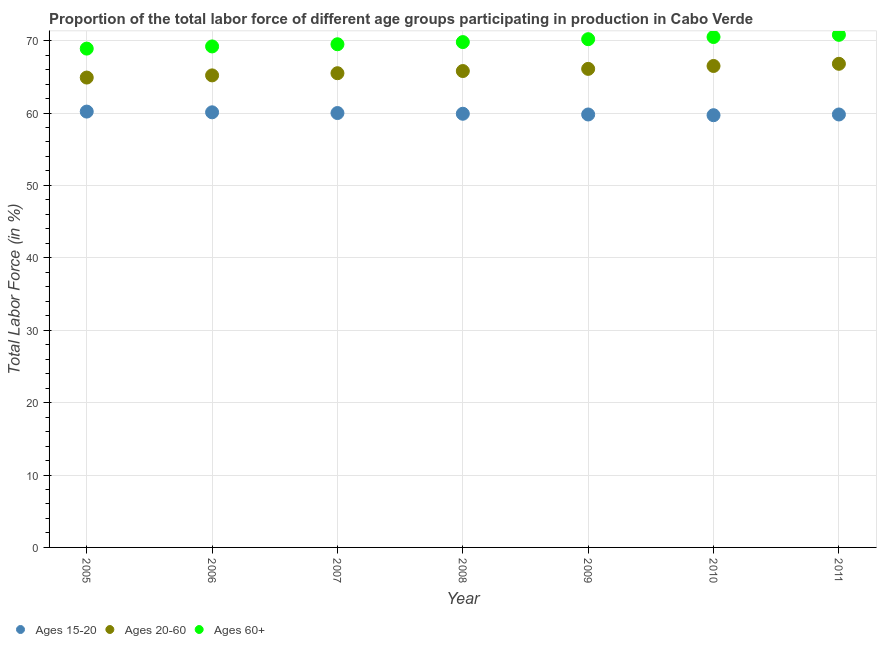Is the number of dotlines equal to the number of legend labels?
Your answer should be compact. Yes. What is the percentage of labor force within the age group 15-20 in 2005?
Your answer should be compact. 60.2. Across all years, what is the maximum percentage of labor force within the age group 20-60?
Your response must be concise. 66.8. Across all years, what is the minimum percentage of labor force within the age group 15-20?
Provide a short and direct response. 59.7. In which year was the percentage of labor force within the age group 20-60 maximum?
Keep it short and to the point. 2011. In which year was the percentage of labor force within the age group 20-60 minimum?
Your response must be concise. 2005. What is the total percentage of labor force within the age group 20-60 in the graph?
Your answer should be very brief. 460.8. What is the difference between the percentage of labor force within the age group 20-60 in 2010 and that in 2011?
Ensure brevity in your answer.  -0.3. What is the difference between the percentage of labor force within the age group 20-60 in 2011 and the percentage of labor force above age 60 in 2009?
Give a very brief answer. -3.4. What is the average percentage of labor force within the age group 20-60 per year?
Your response must be concise. 65.83. In the year 2006, what is the difference between the percentage of labor force within the age group 15-20 and percentage of labor force within the age group 20-60?
Your response must be concise. -5.1. In how many years, is the percentage of labor force within the age group 15-20 greater than 24 %?
Provide a succinct answer. 7. What is the ratio of the percentage of labor force above age 60 in 2009 to that in 2010?
Give a very brief answer. 1. Is the percentage of labor force within the age group 15-20 in 2009 less than that in 2011?
Your answer should be compact. No. What is the difference between the highest and the second highest percentage of labor force within the age group 20-60?
Provide a succinct answer. 0.3. What is the difference between the highest and the lowest percentage of labor force within the age group 20-60?
Provide a short and direct response. 1.9. Is the sum of the percentage of labor force within the age group 15-20 in 2007 and 2009 greater than the maximum percentage of labor force within the age group 20-60 across all years?
Give a very brief answer. Yes. Is it the case that in every year, the sum of the percentage of labor force within the age group 15-20 and percentage of labor force within the age group 20-60 is greater than the percentage of labor force above age 60?
Offer a terse response. Yes. Is the percentage of labor force within the age group 15-20 strictly less than the percentage of labor force within the age group 20-60 over the years?
Make the answer very short. Yes. How many dotlines are there?
Your response must be concise. 3. What is the difference between two consecutive major ticks on the Y-axis?
Give a very brief answer. 10. Are the values on the major ticks of Y-axis written in scientific E-notation?
Provide a succinct answer. No. Does the graph contain grids?
Your answer should be compact. Yes. How many legend labels are there?
Offer a very short reply. 3. What is the title of the graph?
Provide a succinct answer. Proportion of the total labor force of different age groups participating in production in Cabo Verde. What is the Total Labor Force (in %) of Ages 15-20 in 2005?
Your answer should be very brief. 60.2. What is the Total Labor Force (in %) in Ages 20-60 in 2005?
Your response must be concise. 64.9. What is the Total Labor Force (in %) of Ages 60+ in 2005?
Keep it short and to the point. 68.9. What is the Total Labor Force (in %) in Ages 15-20 in 2006?
Your response must be concise. 60.1. What is the Total Labor Force (in %) of Ages 20-60 in 2006?
Give a very brief answer. 65.2. What is the Total Labor Force (in %) of Ages 60+ in 2006?
Offer a terse response. 69.2. What is the Total Labor Force (in %) in Ages 20-60 in 2007?
Provide a short and direct response. 65.5. What is the Total Labor Force (in %) in Ages 60+ in 2007?
Your answer should be compact. 69.5. What is the Total Labor Force (in %) of Ages 15-20 in 2008?
Your answer should be very brief. 59.9. What is the Total Labor Force (in %) in Ages 20-60 in 2008?
Give a very brief answer. 65.8. What is the Total Labor Force (in %) of Ages 60+ in 2008?
Offer a very short reply. 69.8. What is the Total Labor Force (in %) of Ages 15-20 in 2009?
Provide a short and direct response. 59.8. What is the Total Labor Force (in %) in Ages 20-60 in 2009?
Your response must be concise. 66.1. What is the Total Labor Force (in %) of Ages 60+ in 2009?
Offer a very short reply. 70.2. What is the Total Labor Force (in %) of Ages 15-20 in 2010?
Offer a terse response. 59.7. What is the Total Labor Force (in %) in Ages 20-60 in 2010?
Your answer should be very brief. 66.5. What is the Total Labor Force (in %) in Ages 60+ in 2010?
Your answer should be very brief. 70.5. What is the Total Labor Force (in %) in Ages 15-20 in 2011?
Keep it short and to the point. 59.8. What is the Total Labor Force (in %) in Ages 20-60 in 2011?
Offer a very short reply. 66.8. What is the Total Labor Force (in %) in Ages 60+ in 2011?
Make the answer very short. 70.8. Across all years, what is the maximum Total Labor Force (in %) in Ages 15-20?
Provide a succinct answer. 60.2. Across all years, what is the maximum Total Labor Force (in %) in Ages 20-60?
Keep it short and to the point. 66.8. Across all years, what is the maximum Total Labor Force (in %) in Ages 60+?
Provide a short and direct response. 70.8. Across all years, what is the minimum Total Labor Force (in %) of Ages 15-20?
Give a very brief answer. 59.7. Across all years, what is the minimum Total Labor Force (in %) in Ages 20-60?
Offer a very short reply. 64.9. Across all years, what is the minimum Total Labor Force (in %) in Ages 60+?
Your answer should be compact. 68.9. What is the total Total Labor Force (in %) of Ages 15-20 in the graph?
Provide a succinct answer. 419.5. What is the total Total Labor Force (in %) in Ages 20-60 in the graph?
Keep it short and to the point. 460.8. What is the total Total Labor Force (in %) in Ages 60+ in the graph?
Your response must be concise. 488.9. What is the difference between the Total Labor Force (in %) in Ages 15-20 in 2005 and that in 2006?
Your answer should be compact. 0.1. What is the difference between the Total Labor Force (in %) of Ages 20-60 in 2005 and that in 2006?
Your answer should be compact. -0.3. What is the difference between the Total Labor Force (in %) of Ages 15-20 in 2005 and that in 2007?
Keep it short and to the point. 0.2. What is the difference between the Total Labor Force (in %) in Ages 60+ in 2005 and that in 2007?
Give a very brief answer. -0.6. What is the difference between the Total Labor Force (in %) in Ages 20-60 in 2005 and that in 2008?
Provide a succinct answer. -0.9. What is the difference between the Total Labor Force (in %) in Ages 60+ in 2005 and that in 2008?
Offer a terse response. -0.9. What is the difference between the Total Labor Force (in %) of Ages 15-20 in 2005 and that in 2009?
Provide a succinct answer. 0.4. What is the difference between the Total Labor Force (in %) of Ages 20-60 in 2005 and that in 2009?
Make the answer very short. -1.2. What is the difference between the Total Labor Force (in %) in Ages 20-60 in 2005 and that in 2010?
Provide a succinct answer. -1.6. What is the difference between the Total Labor Force (in %) in Ages 20-60 in 2006 and that in 2007?
Provide a short and direct response. -0.3. What is the difference between the Total Labor Force (in %) in Ages 60+ in 2006 and that in 2009?
Your answer should be compact. -1. What is the difference between the Total Labor Force (in %) of Ages 60+ in 2006 and that in 2010?
Make the answer very short. -1.3. What is the difference between the Total Labor Force (in %) of Ages 20-60 in 2006 and that in 2011?
Ensure brevity in your answer.  -1.6. What is the difference between the Total Labor Force (in %) of Ages 20-60 in 2007 and that in 2008?
Give a very brief answer. -0.3. What is the difference between the Total Labor Force (in %) of Ages 15-20 in 2007 and that in 2009?
Offer a terse response. 0.2. What is the difference between the Total Labor Force (in %) in Ages 60+ in 2007 and that in 2009?
Your response must be concise. -0.7. What is the difference between the Total Labor Force (in %) in Ages 15-20 in 2007 and that in 2010?
Offer a very short reply. 0.3. What is the difference between the Total Labor Force (in %) in Ages 60+ in 2007 and that in 2010?
Your answer should be compact. -1. What is the difference between the Total Labor Force (in %) in Ages 20-60 in 2008 and that in 2009?
Keep it short and to the point. -0.3. What is the difference between the Total Labor Force (in %) in Ages 60+ in 2008 and that in 2009?
Your answer should be compact. -0.4. What is the difference between the Total Labor Force (in %) of Ages 15-20 in 2008 and that in 2010?
Provide a short and direct response. 0.2. What is the difference between the Total Labor Force (in %) in Ages 15-20 in 2009 and that in 2010?
Your response must be concise. 0.1. What is the difference between the Total Labor Force (in %) in Ages 15-20 in 2009 and that in 2011?
Ensure brevity in your answer.  0. What is the difference between the Total Labor Force (in %) in Ages 20-60 in 2010 and that in 2011?
Provide a short and direct response. -0.3. What is the difference between the Total Labor Force (in %) in Ages 60+ in 2010 and that in 2011?
Your answer should be compact. -0.3. What is the difference between the Total Labor Force (in %) of Ages 15-20 in 2005 and the Total Labor Force (in %) of Ages 60+ in 2006?
Provide a short and direct response. -9. What is the difference between the Total Labor Force (in %) in Ages 20-60 in 2005 and the Total Labor Force (in %) in Ages 60+ in 2006?
Your answer should be compact. -4.3. What is the difference between the Total Labor Force (in %) in Ages 20-60 in 2005 and the Total Labor Force (in %) in Ages 60+ in 2007?
Offer a terse response. -4.6. What is the difference between the Total Labor Force (in %) in Ages 15-20 in 2005 and the Total Labor Force (in %) in Ages 20-60 in 2009?
Keep it short and to the point. -5.9. What is the difference between the Total Labor Force (in %) in Ages 15-20 in 2005 and the Total Labor Force (in %) in Ages 20-60 in 2010?
Your answer should be very brief. -6.3. What is the difference between the Total Labor Force (in %) of Ages 20-60 in 2005 and the Total Labor Force (in %) of Ages 60+ in 2010?
Offer a very short reply. -5.6. What is the difference between the Total Labor Force (in %) of Ages 15-20 in 2005 and the Total Labor Force (in %) of Ages 20-60 in 2011?
Ensure brevity in your answer.  -6.6. What is the difference between the Total Labor Force (in %) of Ages 15-20 in 2006 and the Total Labor Force (in %) of Ages 20-60 in 2007?
Keep it short and to the point. -5.4. What is the difference between the Total Labor Force (in %) in Ages 15-20 in 2006 and the Total Labor Force (in %) in Ages 60+ in 2008?
Your answer should be very brief. -9.7. What is the difference between the Total Labor Force (in %) of Ages 20-60 in 2006 and the Total Labor Force (in %) of Ages 60+ in 2009?
Offer a very short reply. -5. What is the difference between the Total Labor Force (in %) in Ages 15-20 in 2006 and the Total Labor Force (in %) in Ages 20-60 in 2010?
Offer a terse response. -6.4. What is the difference between the Total Labor Force (in %) in Ages 15-20 in 2006 and the Total Labor Force (in %) in Ages 20-60 in 2011?
Provide a succinct answer. -6.7. What is the difference between the Total Labor Force (in %) in Ages 20-60 in 2007 and the Total Labor Force (in %) in Ages 60+ in 2008?
Keep it short and to the point. -4.3. What is the difference between the Total Labor Force (in %) in Ages 15-20 in 2007 and the Total Labor Force (in %) in Ages 20-60 in 2009?
Provide a short and direct response. -6.1. What is the difference between the Total Labor Force (in %) of Ages 15-20 in 2007 and the Total Labor Force (in %) of Ages 60+ in 2009?
Ensure brevity in your answer.  -10.2. What is the difference between the Total Labor Force (in %) of Ages 20-60 in 2007 and the Total Labor Force (in %) of Ages 60+ in 2010?
Give a very brief answer. -5. What is the difference between the Total Labor Force (in %) of Ages 15-20 in 2007 and the Total Labor Force (in %) of Ages 60+ in 2011?
Give a very brief answer. -10.8. What is the difference between the Total Labor Force (in %) of Ages 20-60 in 2007 and the Total Labor Force (in %) of Ages 60+ in 2011?
Your response must be concise. -5.3. What is the difference between the Total Labor Force (in %) of Ages 15-20 in 2008 and the Total Labor Force (in %) of Ages 20-60 in 2009?
Provide a short and direct response. -6.2. What is the difference between the Total Labor Force (in %) in Ages 15-20 in 2008 and the Total Labor Force (in %) in Ages 20-60 in 2010?
Give a very brief answer. -6.6. What is the difference between the Total Labor Force (in %) of Ages 15-20 in 2008 and the Total Labor Force (in %) of Ages 20-60 in 2011?
Keep it short and to the point. -6.9. What is the difference between the Total Labor Force (in %) in Ages 15-20 in 2008 and the Total Labor Force (in %) in Ages 60+ in 2011?
Keep it short and to the point. -10.9. What is the difference between the Total Labor Force (in %) in Ages 20-60 in 2008 and the Total Labor Force (in %) in Ages 60+ in 2011?
Your answer should be very brief. -5. What is the difference between the Total Labor Force (in %) in Ages 15-20 in 2009 and the Total Labor Force (in %) in Ages 60+ in 2010?
Your answer should be compact. -10.7. What is the difference between the Total Labor Force (in %) in Ages 15-20 in 2009 and the Total Labor Force (in %) in Ages 20-60 in 2011?
Make the answer very short. -7. What is the difference between the Total Labor Force (in %) in Ages 15-20 in 2010 and the Total Labor Force (in %) in Ages 20-60 in 2011?
Provide a succinct answer. -7.1. What is the difference between the Total Labor Force (in %) of Ages 20-60 in 2010 and the Total Labor Force (in %) of Ages 60+ in 2011?
Make the answer very short. -4.3. What is the average Total Labor Force (in %) of Ages 15-20 per year?
Ensure brevity in your answer.  59.93. What is the average Total Labor Force (in %) of Ages 20-60 per year?
Offer a terse response. 65.83. What is the average Total Labor Force (in %) in Ages 60+ per year?
Keep it short and to the point. 69.84. In the year 2005, what is the difference between the Total Labor Force (in %) of Ages 15-20 and Total Labor Force (in %) of Ages 60+?
Offer a terse response. -8.7. In the year 2006, what is the difference between the Total Labor Force (in %) of Ages 15-20 and Total Labor Force (in %) of Ages 20-60?
Offer a very short reply. -5.1. In the year 2008, what is the difference between the Total Labor Force (in %) of Ages 15-20 and Total Labor Force (in %) of Ages 20-60?
Your response must be concise. -5.9. In the year 2009, what is the difference between the Total Labor Force (in %) of Ages 15-20 and Total Labor Force (in %) of Ages 20-60?
Provide a short and direct response. -6.3. In the year 2010, what is the difference between the Total Labor Force (in %) in Ages 20-60 and Total Labor Force (in %) in Ages 60+?
Keep it short and to the point. -4. In the year 2011, what is the difference between the Total Labor Force (in %) of Ages 15-20 and Total Labor Force (in %) of Ages 60+?
Provide a succinct answer. -11. In the year 2011, what is the difference between the Total Labor Force (in %) of Ages 20-60 and Total Labor Force (in %) of Ages 60+?
Give a very brief answer. -4. What is the ratio of the Total Labor Force (in %) of Ages 15-20 in 2005 to that in 2006?
Ensure brevity in your answer.  1. What is the ratio of the Total Labor Force (in %) of Ages 20-60 in 2005 to that in 2006?
Ensure brevity in your answer.  1. What is the ratio of the Total Labor Force (in %) of Ages 15-20 in 2005 to that in 2008?
Ensure brevity in your answer.  1. What is the ratio of the Total Labor Force (in %) in Ages 20-60 in 2005 to that in 2008?
Offer a very short reply. 0.99. What is the ratio of the Total Labor Force (in %) of Ages 60+ in 2005 to that in 2008?
Offer a terse response. 0.99. What is the ratio of the Total Labor Force (in %) in Ages 15-20 in 2005 to that in 2009?
Ensure brevity in your answer.  1.01. What is the ratio of the Total Labor Force (in %) in Ages 20-60 in 2005 to that in 2009?
Your answer should be compact. 0.98. What is the ratio of the Total Labor Force (in %) of Ages 60+ in 2005 to that in 2009?
Give a very brief answer. 0.98. What is the ratio of the Total Labor Force (in %) in Ages 15-20 in 2005 to that in 2010?
Your response must be concise. 1.01. What is the ratio of the Total Labor Force (in %) of Ages 20-60 in 2005 to that in 2010?
Provide a short and direct response. 0.98. What is the ratio of the Total Labor Force (in %) in Ages 60+ in 2005 to that in 2010?
Offer a terse response. 0.98. What is the ratio of the Total Labor Force (in %) in Ages 20-60 in 2005 to that in 2011?
Provide a short and direct response. 0.97. What is the ratio of the Total Labor Force (in %) in Ages 60+ in 2005 to that in 2011?
Give a very brief answer. 0.97. What is the ratio of the Total Labor Force (in %) in Ages 20-60 in 2006 to that in 2007?
Offer a very short reply. 1. What is the ratio of the Total Labor Force (in %) of Ages 20-60 in 2006 to that in 2008?
Ensure brevity in your answer.  0.99. What is the ratio of the Total Labor Force (in %) in Ages 60+ in 2006 to that in 2008?
Give a very brief answer. 0.99. What is the ratio of the Total Labor Force (in %) of Ages 20-60 in 2006 to that in 2009?
Give a very brief answer. 0.99. What is the ratio of the Total Labor Force (in %) in Ages 60+ in 2006 to that in 2009?
Make the answer very short. 0.99. What is the ratio of the Total Labor Force (in %) in Ages 20-60 in 2006 to that in 2010?
Your response must be concise. 0.98. What is the ratio of the Total Labor Force (in %) of Ages 60+ in 2006 to that in 2010?
Your answer should be compact. 0.98. What is the ratio of the Total Labor Force (in %) of Ages 15-20 in 2006 to that in 2011?
Your answer should be very brief. 1. What is the ratio of the Total Labor Force (in %) in Ages 20-60 in 2006 to that in 2011?
Your answer should be very brief. 0.98. What is the ratio of the Total Labor Force (in %) in Ages 60+ in 2006 to that in 2011?
Give a very brief answer. 0.98. What is the ratio of the Total Labor Force (in %) in Ages 15-20 in 2007 to that in 2008?
Give a very brief answer. 1. What is the ratio of the Total Labor Force (in %) of Ages 20-60 in 2007 to that in 2008?
Your response must be concise. 1. What is the ratio of the Total Labor Force (in %) of Ages 60+ in 2007 to that in 2008?
Keep it short and to the point. 1. What is the ratio of the Total Labor Force (in %) in Ages 20-60 in 2007 to that in 2009?
Your response must be concise. 0.99. What is the ratio of the Total Labor Force (in %) in Ages 15-20 in 2007 to that in 2010?
Your answer should be compact. 1. What is the ratio of the Total Labor Force (in %) of Ages 60+ in 2007 to that in 2010?
Offer a very short reply. 0.99. What is the ratio of the Total Labor Force (in %) of Ages 20-60 in 2007 to that in 2011?
Offer a very short reply. 0.98. What is the ratio of the Total Labor Force (in %) of Ages 60+ in 2007 to that in 2011?
Give a very brief answer. 0.98. What is the ratio of the Total Labor Force (in %) of Ages 15-20 in 2008 to that in 2009?
Provide a short and direct response. 1. What is the ratio of the Total Labor Force (in %) in Ages 20-60 in 2008 to that in 2009?
Offer a terse response. 1. What is the ratio of the Total Labor Force (in %) of Ages 15-20 in 2008 to that in 2010?
Give a very brief answer. 1. What is the ratio of the Total Labor Force (in %) of Ages 20-60 in 2008 to that in 2010?
Your response must be concise. 0.99. What is the ratio of the Total Labor Force (in %) of Ages 60+ in 2008 to that in 2010?
Keep it short and to the point. 0.99. What is the ratio of the Total Labor Force (in %) of Ages 20-60 in 2008 to that in 2011?
Your answer should be compact. 0.98. What is the ratio of the Total Labor Force (in %) in Ages 60+ in 2008 to that in 2011?
Offer a terse response. 0.99. What is the ratio of the Total Labor Force (in %) of Ages 20-60 in 2009 to that in 2010?
Offer a terse response. 0.99. What is the ratio of the Total Labor Force (in %) in Ages 60+ in 2009 to that in 2010?
Your answer should be very brief. 1. What is the ratio of the Total Labor Force (in %) in Ages 15-20 in 2010 to that in 2011?
Keep it short and to the point. 1. What is the ratio of the Total Labor Force (in %) in Ages 20-60 in 2010 to that in 2011?
Provide a succinct answer. 1. What is the ratio of the Total Labor Force (in %) in Ages 60+ in 2010 to that in 2011?
Offer a terse response. 1. What is the difference between the highest and the second highest Total Labor Force (in %) of Ages 15-20?
Your response must be concise. 0.1. What is the difference between the highest and the lowest Total Labor Force (in %) of Ages 20-60?
Your answer should be compact. 1.9. 